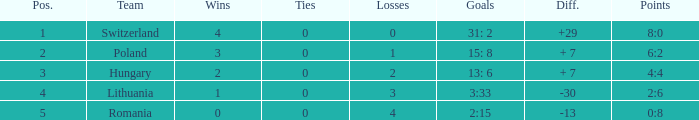Which team had fewer than 2 losses and a position number more than 1? Poland. 